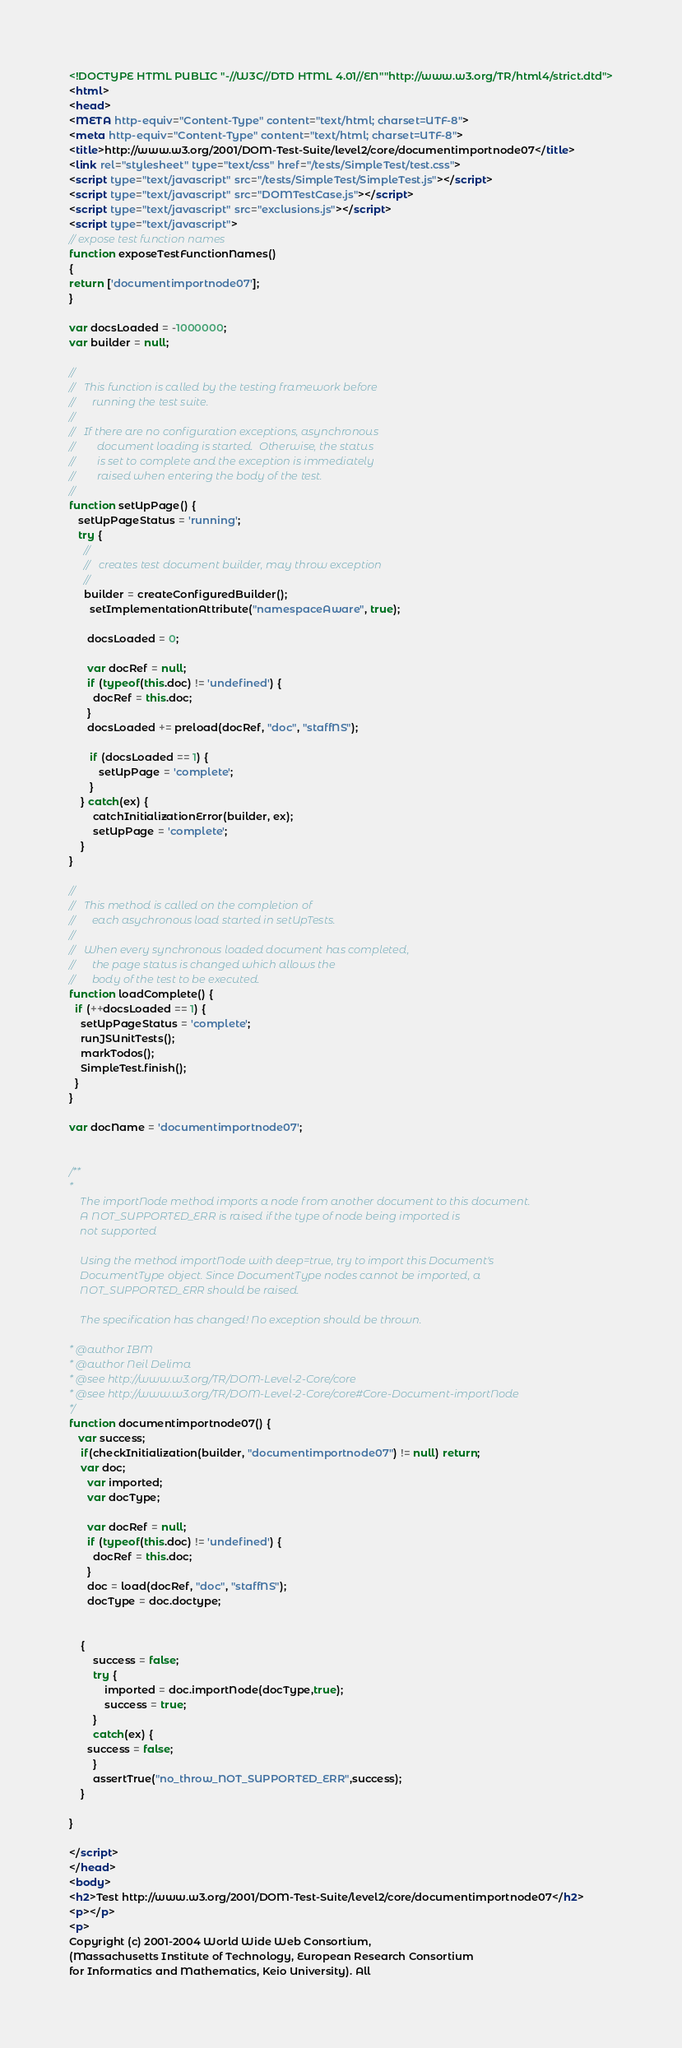<code> <loc_0><loc_0><loc_500><loc_500><_HTML_><!DOCTYPE HTML PUBLIC "-//W3C//DTD HTML 4.01//EN""http://www.w3.org/TR/html4/strict.dtd">
<html>
<head>
<META http-equiv="Content-Type" content="text/html; charset=UTF-8">
<meta http-equiv="Content-Type" content="text/html; charset=UTF-8">
<title>http://www.w3.org/2001/DOM-Test-Suite/level2/core/documentimportnode07</title>
<link rel="stylesheet" type="text/css" href="/tests/SimpleTest/test.css">
<script type="text/javascript" src="/tests/SimpleTest/SimpleTest.js"></script>
<script type="text/javascript" src="DOMTestCase.js"></script>
<script type="text/javascript" src="exclusions.js"></script>
<script type="text/javascript">
// expose test function names
function exposeTestFunctionNames()
{
return ['documentimportnode07'];
}

var docsLoaded = -1000000;
var builder = null;

//
//   This function is called by the testing framework before
//      running the test suite.
//
//   If there are no configuration exceptions, asynchronous
//        document loading is started.  Otherwise, the status
//        is set to complete and the exception is immediately
//        raised when entering the body of the test.
//
function setUpPage() {
   setUpPageStatus = 'running';
   try {
     //
     //   creates test document builder, may throw exception
     //
     builder = createConfiguredBuilder();
       setImplementationAttribute("namespaceAware", true);

      docsLoaded = 0;
      
      var docRef = null;
      if (typeof(this.doc) != 'undefined') {
        docRef = this.doc;
      }
      docsLoaded += preload(docRef, "doc", "staffNS");
        
       if (docsLoaded == 1) {
          setUpPage = 'complete';
       }
    } catch(ex) {
    	catchInitializationError(builder, ex);
        setUpPage = 'complete';
    }
}

//
//   This method is called on the completion of 
//      each asychronous load started in setUpTests.
//
//   When every synchronous loaded document has completed,
//      the page status is changed which allows the
//      body of the test to be executed.
function loadComplete() {
  if (++docsLoaded == 1) {
    setUpPageStatus = 'complete';
    runJSUnitTests();
    markTodos();
    SimpleTest.finish();
  }
}

var docName = 'documentimportnode07';


/**
* 
	The importNode method imports a node from another document to this document. 
	A NOT_SUPPORTED_ERR is raised if the type of node being imported is
	not supported
	
	Using the method importNode with deep=true, try to import this Document's 
	DocumentType object. Since DocumentType nodes cannot be imported, a 
	NOT_SUPPORTED_ERR should be raised.

	The specification has changed! No exception should be thrown.

* @author IBM
* @author Neil Delima
* @see http://www.w3.org/TR/DOM-Level-2-Core/core
* @see http://www.w3.org/TR/DOM-Level-2-Core/core#Core-Document-importNode
*/
function documentimportnode07() {
   var success;
    if(checkInitialization(builder, "documentimportnode07") != null) return;
    var doc;
      var imported;
      var docType;
      
      var docRef = null;
      if (typeof(this.doc) != 'undefined') {
        docRef = this.doc;
      }
      doc = load(docRef, "doc", "staffNS");
      docType = doc.doctype;

      
	{
		success = false;
		try {
            imported = doc.importNode(docType,true);
            success = true;
        }
		catch(ex) {
      success = false;
		}
		assertTrue("no_throw_NOT_SUPPORTED_ERR",success);
	}

}

</script>
</head>
<body>
<h2>Test http://www.w3.org/2001/DOM-Test-Suite/level2/core/documentimportnode07</h2>
<p></p>
<p>
Copyright (c) 2001-2004 World Wide Web Consortium, 
(Massachusetts Institute of Technology, European Research Consortium 
for Informatics and Mathematics, Keio University). All </code> 